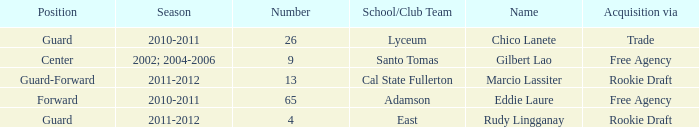What season had Marcio Lassiter? 2011-2012. 